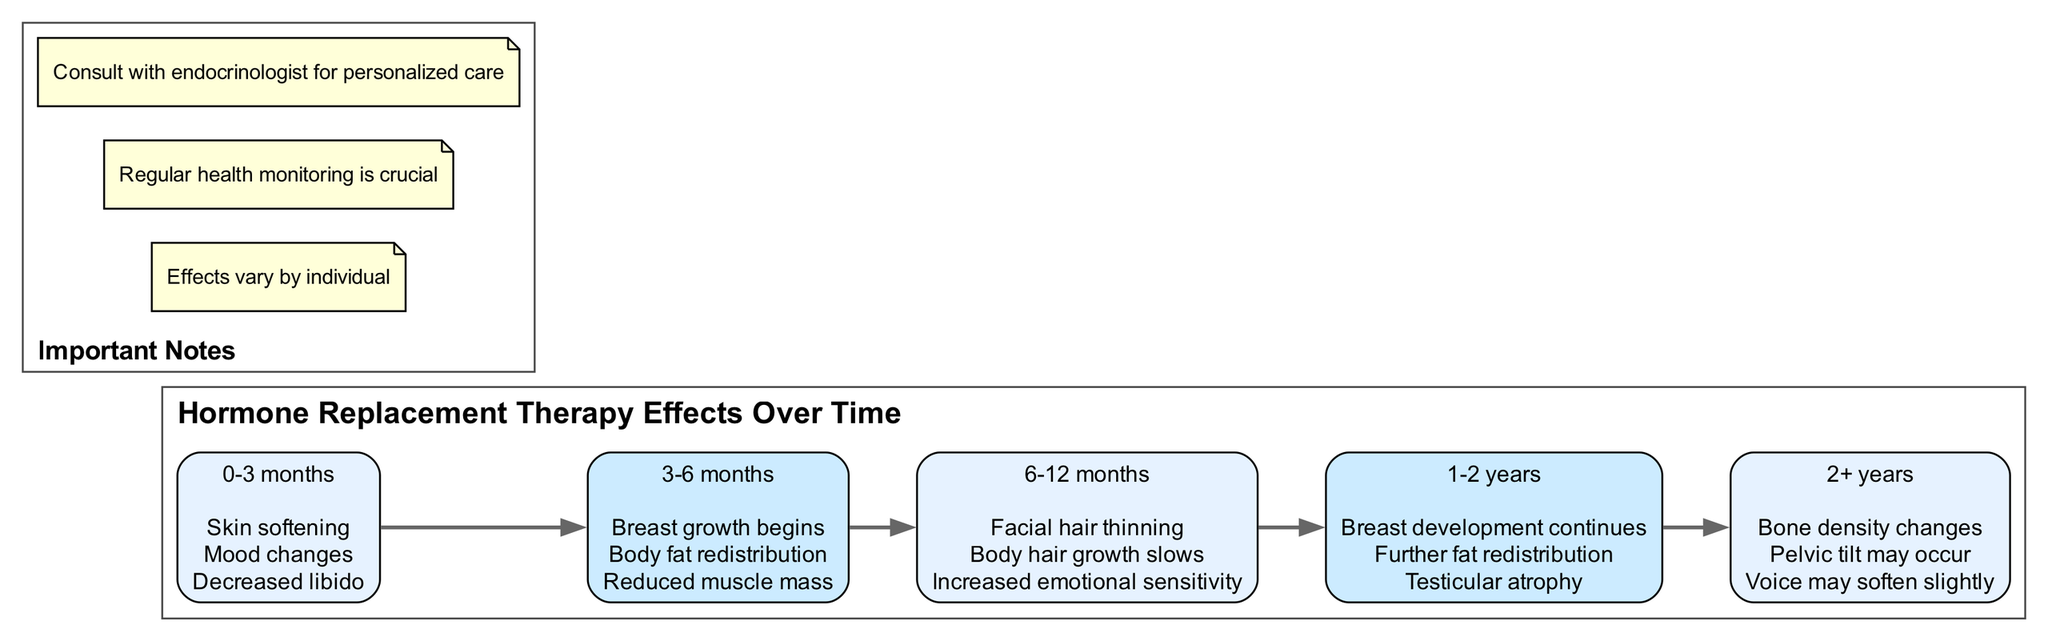What are the effects observed between 0-3 months? The diagram lists three effects for the period 0-3 months: skin softening, mood changes, and decreased libido. These effects can be found in the first node of the timeline.
Answer: Skin softening, mood changes, decreased libido How many periods are listed in the diagram? The diagram contains five distinct periods in the timeline, each detailing specific effects over varying durations. This can be counted by identifying the individual nodes representing each period.
Answer: 5 What is one effect that begins at 3-6 months? According to the diagram, the first effect listed for the 3-6 month period is breast growth begins. This can be found in the second node of the timeline.
Answer: Breast growth begins What changes occur after 2+ years? In the last period (2+ years) of the diagram, three effects are noted: bone density changes, pelvic tilt may occur, and voice may soften slightly. This information can be read from the final node of the timeline.
Answer: Bone density changes, pelvic tilt may occur, voice may soften slightly Which period sees reduced muscle mass? The diagram indicates that reduced muscle mass is an effect observed during the 3-6 month period. This can be confirmed by examining the effects listed under that specific node in the timeline.
Answer: 3-6 months What is critical to note about the effects of hormone replacement therapy? The diagram emphasizes three important notes, including that effects vary by individual, regular health monitoring is crucial, and it is important to consult with an endocrinologist for personalized care. This information is presented in the notes section of the diagram.
Answer: Effects vary by individual What happens to body hair growth after 6-12 months? The diagram states that during the 6-12 month period, body hair growth slows. This specific effect can be found in the third node on the timeline detailing that time period.
Answer: Body hair growth slows What is one effect of HRT observed in the 1-2 year period? The diagram lists that testicular atrophy is an effect observed during the 1-2 year period. This information is found in the fourth node of the timeline.
Answer: Testicular atrophy 